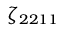Convert formula to latex. <formula><loc_0><loc_0><loc_500><loc_500>\zeta _ { 2 2 1 1 }</formula> 